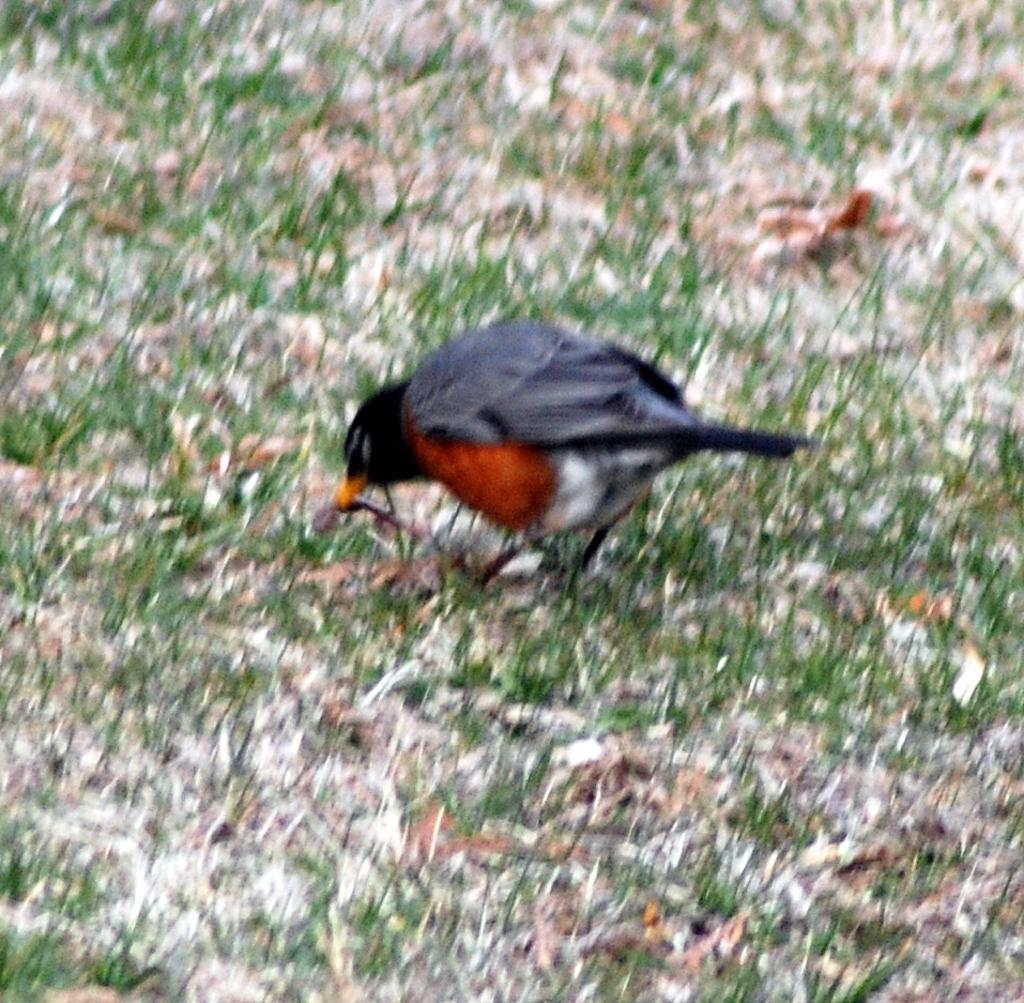What type of animal is present in the image? There is a bird in the image. Where is the bird located? The bird is on a grassy land. How does the bird contribute to the pollution in the image? The image does not show any pollution, and there is no indication that the bird is contributing to any pollution. 